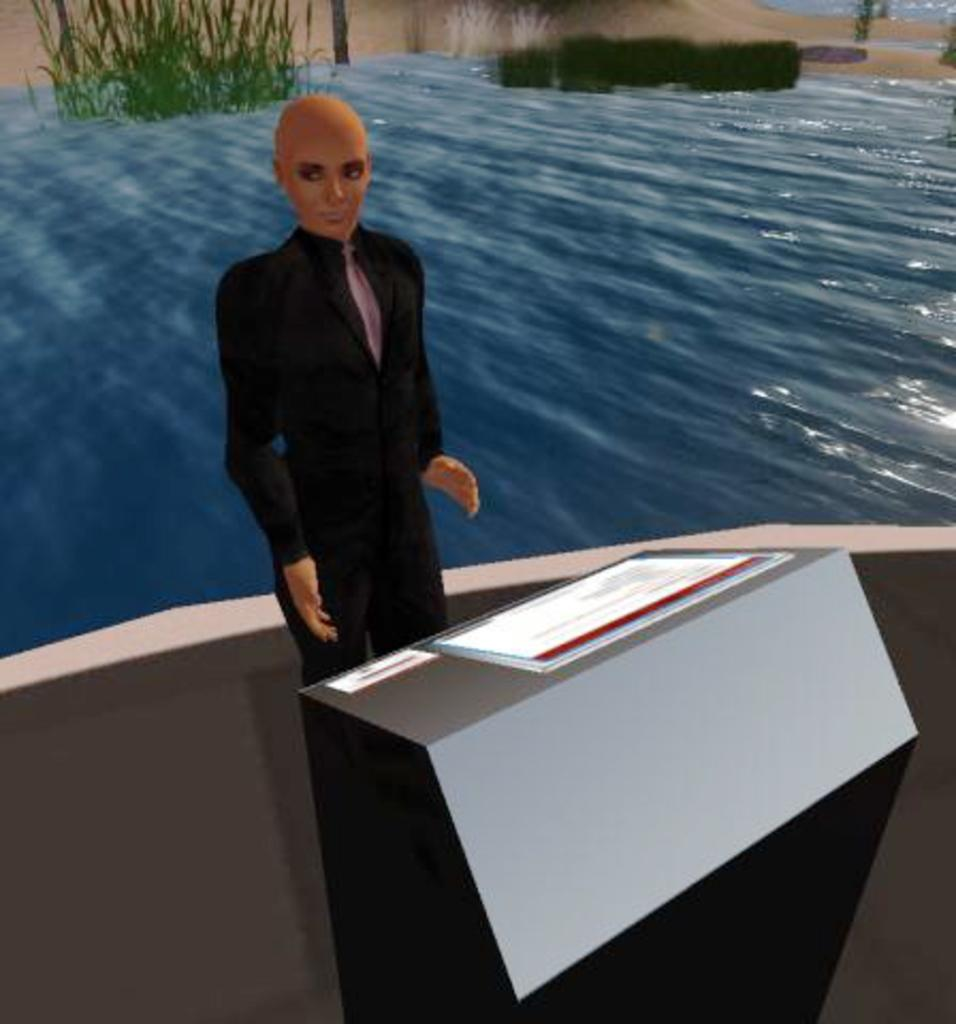What type of image is being described? The image is an animated picture. What is the person in the image doing? The person is standing behind a podium. What can be seen in the background of the image? The background of the image includes water and plants. How many silk scarves are draped over the podium in the image? There is no mention of silk scarves in the image; the focus is on the person standing behind the podium. Can you see any lizards swimming in the water in the background of the image? There is no mention of lizards in the image; the background includes water and plants. 